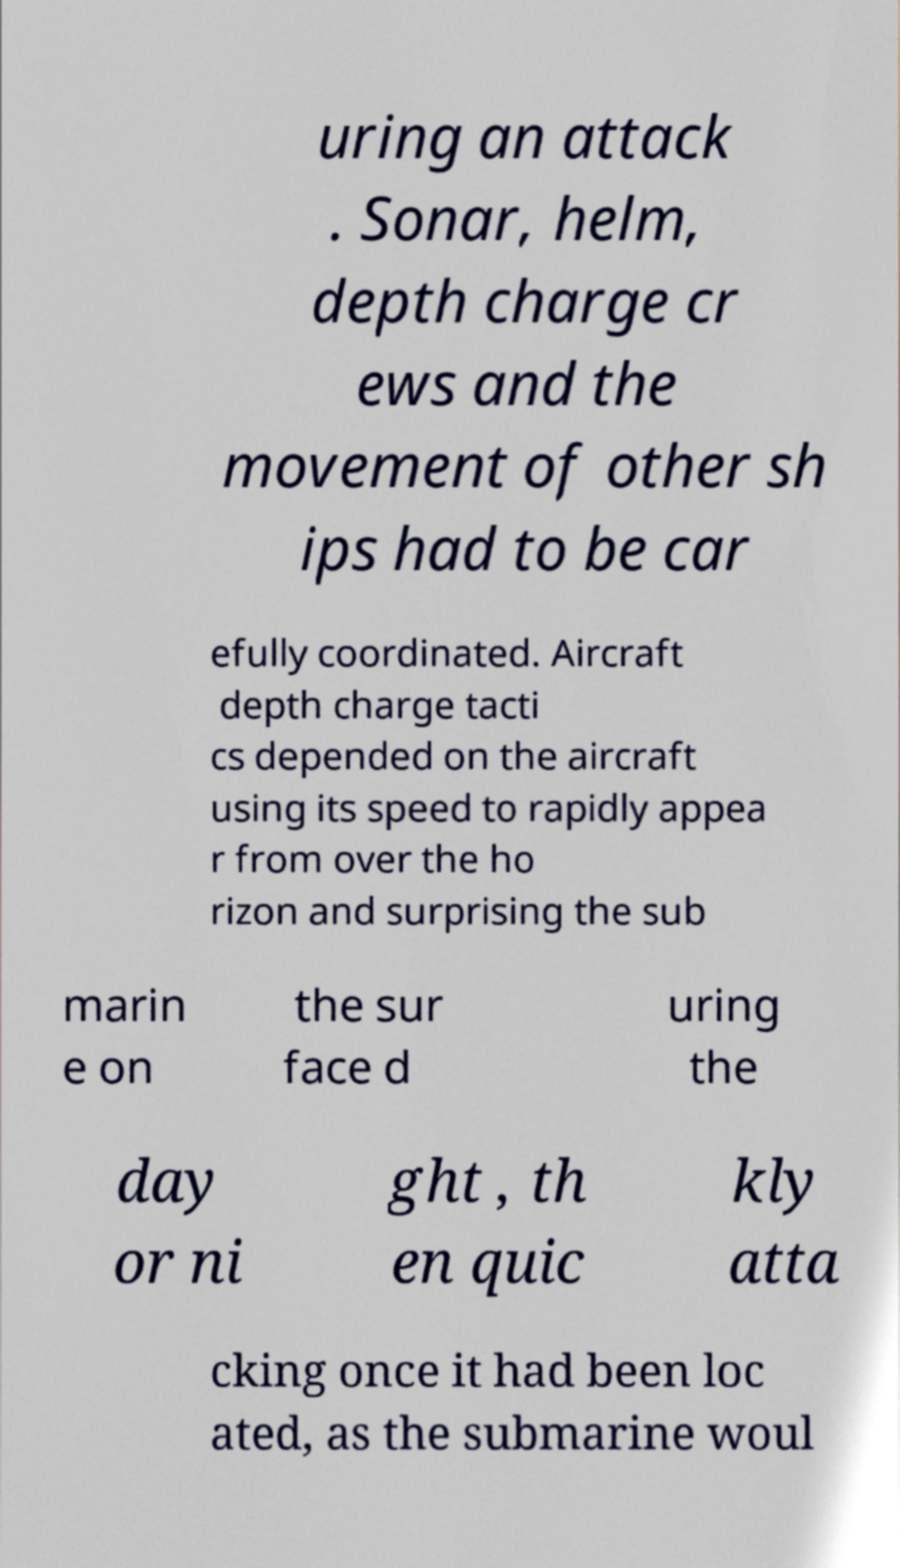Could you extract and type out the text from this image? uring an attack . Sonar, helm, depth charge cr ews and the movement of other sh ips had to be car efully coordinated. Aircraft depth charge tacti cs depended on the aircraft using its speed to rapidly appea r from over the ho rizon and surprising the sub marin e on the sur face d uring the day or ni ght , th en quic kly atta cking once it had been loc ated, as the submarine woul 